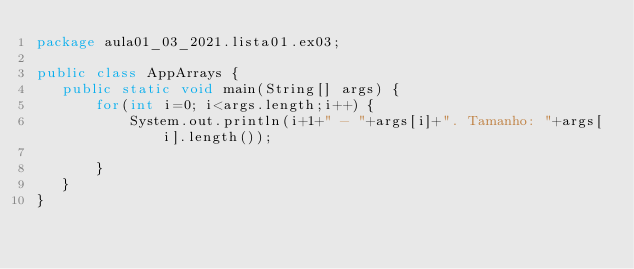<code> <loc_0><loc_0><loc_500><loc_500><_Java_>package aula01_03_2021.lista01.ex03;

public class AppArrays {
   public static void main(String[] args) {
	   for(int i=0; i<args.length;i++) {
		   System.out.println(i+1+" - "+args[i]+". Tamanho: "+args[i].length());
		   
	   }
   }
}
</code> 